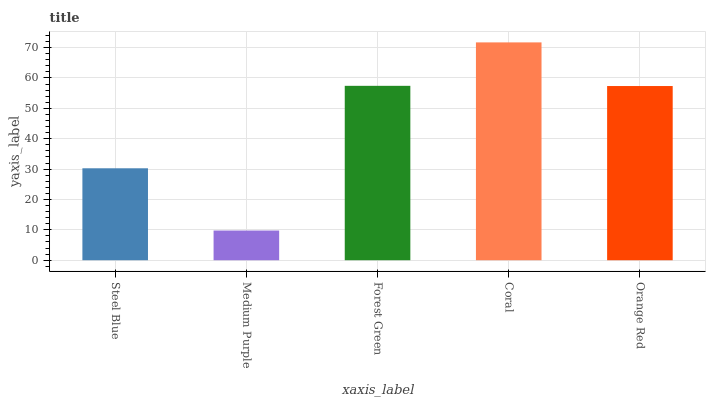Is Medium Purple the minimum?
Answer yes or no. Yes. Is Coral the maximum?
Answer yes or no. Yes. Is Forest Green the minimum?
Answer yes or no. No. Is Forest Green the maximum?
Answer yes or no. No. Is Forest Green greater than Medium Purple?
Answer yes or no. Yes. Is Medium Purple less than Forest Green?
Answer yes or no. Yes. Is Medium Purple greater than Forest Green?
Answer yes or no. No. Is Forest Green less than Medium Purple?
Answer yes or no. No. Is Orange Red the high median?
Answer yes or no. Yes. Is Orange Red the low median?
Answer yes or no. Yes. Is Medium Purple the high median?
Answer yes or no. No. Is Medium Purple the low median?
Answer yes or no. No. 